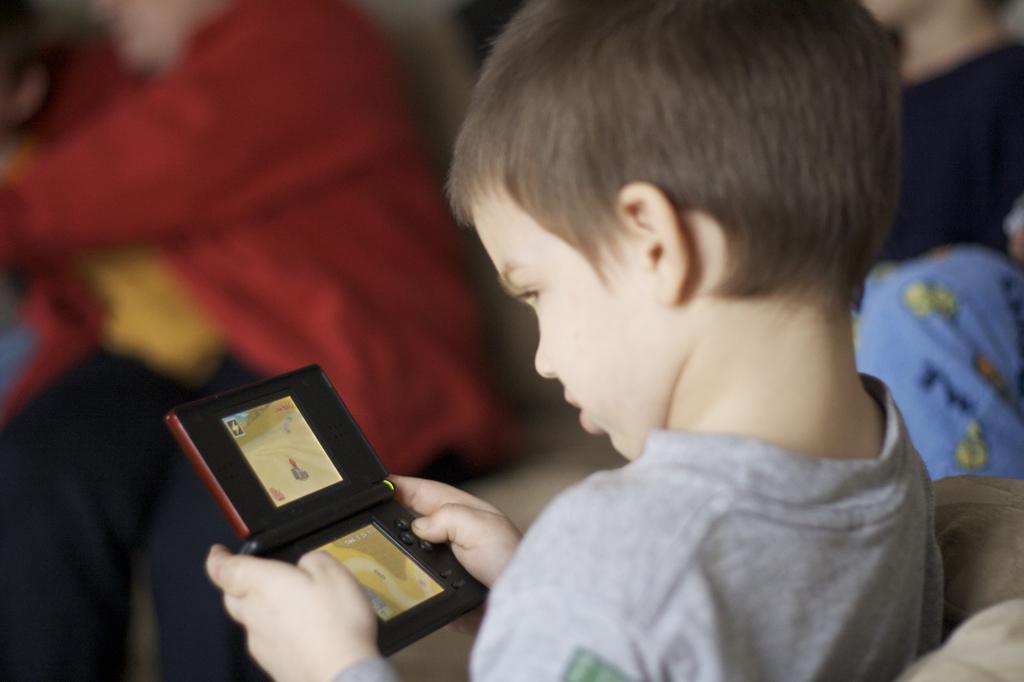Could you give a brief overview of what you see in this image? In this image there is a kid sitting on a chair, holding an object in his hand, in the background there are people sitting and it is blurred. 